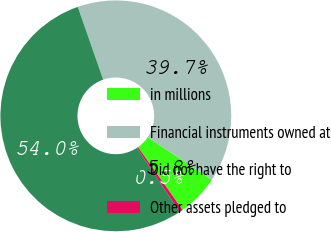Convert chart to OTSL. <chart><loc_0><loc_0><loc_500><loc_500><pie_chart><fcel>in millions<fcel>Financial instruments owned at<fcel>Did not have the right to<fcel>Other assets pledged to<nl><fcel>5.84%<fcel>39.69%<fcel>53.98%<fcel>0.49%<nl></chart> 